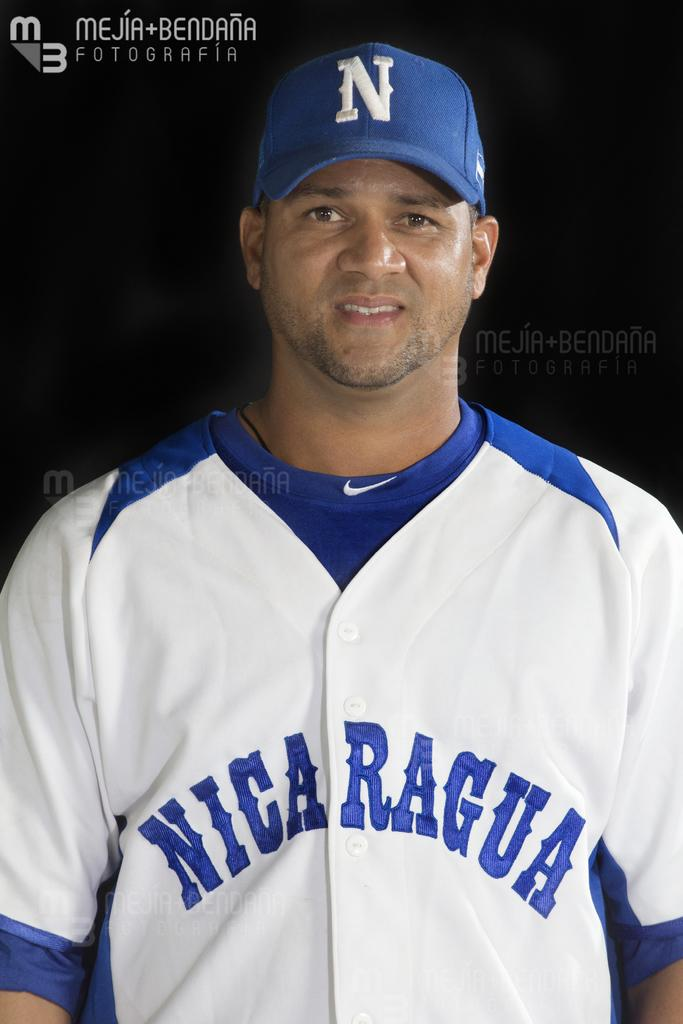<image>
Write a terse but informative summary of the picture. a member of the nicaragua baseball team with his cap on 